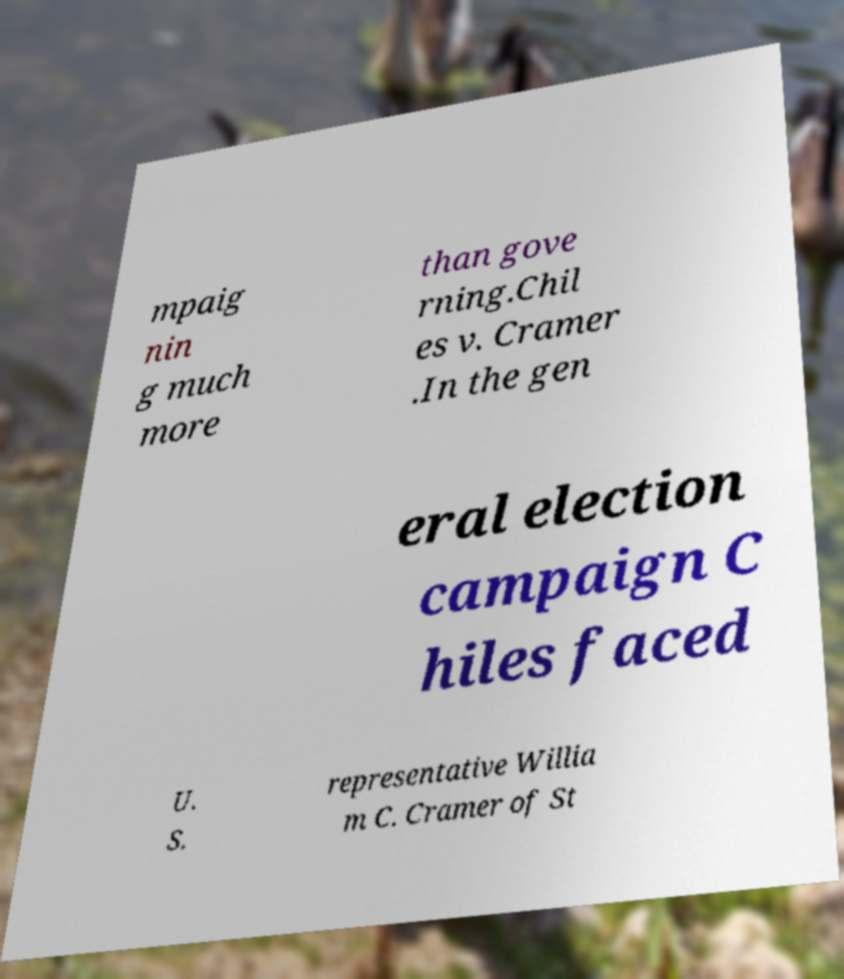Could you assist in decoding the text presented in this image and type it out clearly? mpaig nin g much more than gove rning.Chil es v. Cramer .In the gen eral election campaign C hiles faced U. S. representative Willia m C. Cramer of St 